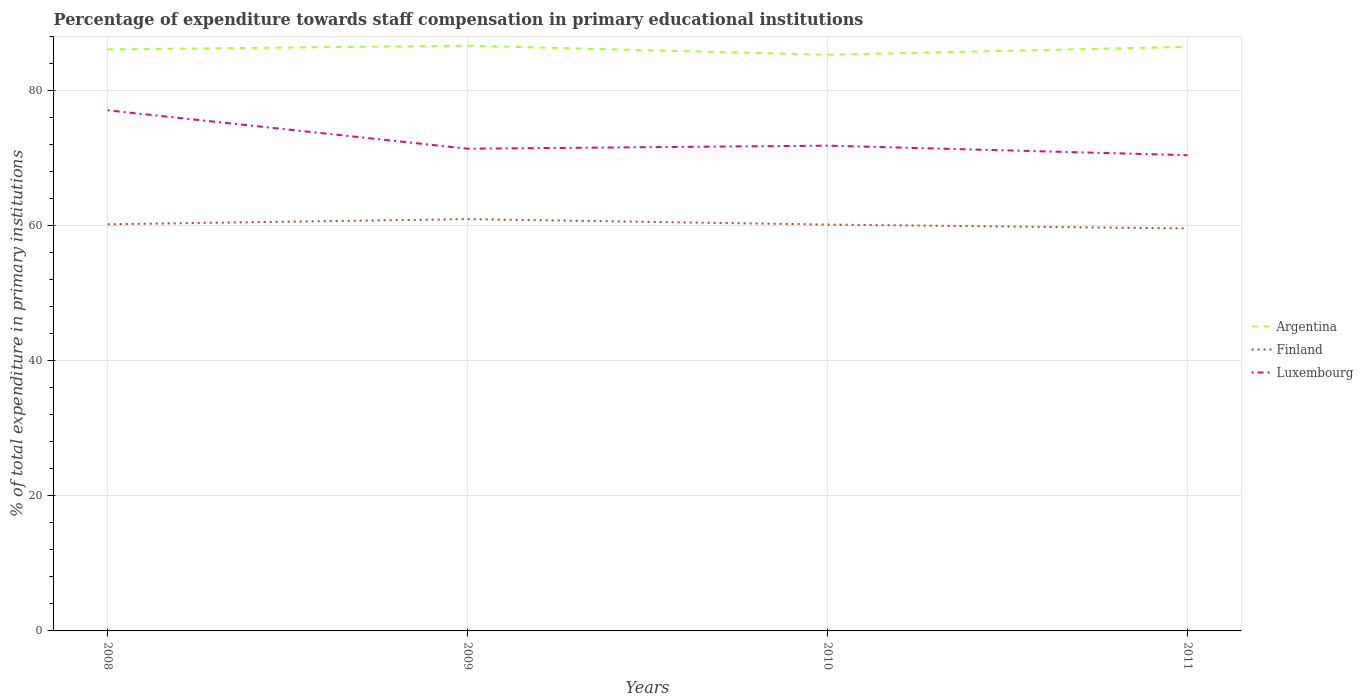Does the line corresponding to Luxembourg intersect with the line corresponding to Finland?
Make the answer very short. No. Across all years, what is the maximum percentage of expenditure towards staff compensation in Finland?
Keep it short and to the point. 59.62. In which year was the percentage of expenditure towards staff compensation in Luxembourg maximum?
Offer a very short reply. 2011. What is the total percentage of expenditure towards staff compensation in Finland in the graph?
Provide a short and direct response. 0.05. What is the difference between the highest and the second highest percentage of expenditure towards staff compensation in Luxembourg?
Your response must be concise. 6.65. What is the difference between the highest and the lowest percentage of expenditure towards staff compensation in Luxembourg?
Provide a short and direct response. 1. Is the percentage of expenditure towards staff compensation in Argentina strictly greater than the percentage of expenditure towards staff compensation in Luxembourg over the years?
Give a very brief answer. No. How many lines are there?
Ensure brevity in your answer.  3. How many years are there in the graph?
Offer a terse response. 4. What is the difference between two consecutive major ticks on the Y-axis?
Keep it short and to the point. 20. Are the values on the major ticks of Y-axis written in scientific E-notation?
Keep it short and to the point. No. Does the graph contain any zero values?
Offer a terse response. No. Does the graph contain grids?
Offer a very short reply. Yes. What is the title of the graph?
Ensure brevity in your answer.  Percentage of expenditure towards staff compensation in primary educational institutions. Does "Burkina Faso" appear as one of the legend labels in the graph?
Offer a terse response. No. What is the label or title of the X-axis?
Make the answer very short. Years. What is the label or title of the Y-axis?
Give a very brief answer. % of total expenditure in primary institutions. What is the % of total expenditure in primary institutions of Argentina in 2008?
Offer a terse response. 86.15. What is the % of total expenditure in primary institutions in Finland in 2008?
Provide a short and direct response. 60.24. What is the % of total expenditure in primary institutions in Luxembourg in 2008?
Your answer should be compact. 77.13. What is the % of total expenditure in primary institutions in Argentina in 2009?
Your answer should be very brief. 86.7. What is the % of total expenditure in primary institutions of Finland in 2009?
Keep it short and to the point. 61.01. What is the % of total expenditure in primary institutions of Luxembourg in 2009?
Your answer should be compact. 71.44. What is the % of total expenditure in primary institutions in Argentina in 2010?
Your answer should be very brief. 85.36. What is the % of total expenditure in primary institutions of Finland in 2010?
Keep it short and to the point. 60.2. What is the % of total expenditure in primary institutions in Luxembourg in 2010?
Your response must be concise. 71.89. What is the % of total expenditure in primary institutions of Argentina in 2011?
Offer a terse response. 86.53. What is the % of total expenditure in primary institutions in Finland in 2011?
Give a very brief answer. 59.62. What is the % of total expenditure in primary institutions in Luxembourg in 2011?
Provide a short and direct response. 70.48. Across all years, what is the maximum % of total expenditure in primary institutions of Argentina?
Your answer should be very brief. 86.7. Across all years, what is the maximum % of total expenditure in primary institutions of Finland?
Offer a terse response. 61.01. Across all years, what is the maximum % of total expenditure in primary institutions of Luxembourg?
Your answer should be very brief. 77.13. Across all years, what is the minimum % of total expenditure in primary institutions of Argentina?
Your response must be concise. 85.36. Across all years, what is the minimum % of total expenditure in primary institutions of Finland?
Your response must be concise. 59.62. Across all years, what is the minimum % of total expenditure in primary institutions of Luxembourg?
Make the answer very short. 70.48. What is the total % of total expenditure in primary institutions of Argentina in the graph?
Keep it short and to the point. 344.74. What is the total % of total expenditure in primary institutions of Finland in the graph?
Keep it short and to the point. 241.07. What is the total % of total expenditure in primary institutions of Luxembourg in the graph?
Your answer should be very brief. 290.94. What is the difference between the % of total expenditure in primary institutions of Argentina in 2008 and that in 2009?
Give a very brief answer. -0.55. What is the difference between the % of total expenditure in primary institutions in Finland in 2008 and that in 2009?
Ensure brevity in your answer.  -0.76. What is the difference between the % of total expenditure in primary institutions of Luxembourg in 2008 and that in 2009?
Offer a terse response. 5.69. What is the difference between the % of total expenditure in primary institutions in Argentina in 2008 and that in 2010?
Make the answer very short. 0.8. What is the difference between the % of total expenditure in primary institutions of Finland in 2008 and that in 2010?
Your answer should be compact. 0.05. What is the difference between the % of total expenditure in primary institutions in Luxembourg in 2008 and that in 2010?
Provide a short and direct response. 5.24. What is the difference between the % of total expenditure in primary institutions in Argentina in 2008 and that in 2011?
Ensure brevity in your answer.  -0.38. What is the difference between the % of total expenditure in primary institutions in Finland in 2008 and that in 2011?
Offer a terse response. 0.62. What is the difference between the % of total expenditure in primary institutions in Luxembourg in 2008 and that in 2011?
Give a very brief answer. 6.65. What is the difference between the % of total expenditure in primary institutions of Argentina in 2009 and that in 2010?
Keep it short and to the point. 1.34. What is the difference between the % of total expenditure in primary institutions in Finland in 2009 and that in 2010?
Your answer should be very brief. 0.81. What is the difference between the % of total expenditure in primary institutions of Luxembourg in 2009 and that in 2010?
Ensure brevity in your answer.  -0.45. What is the difference between the % of total expenditure in primary institutions in Argentina in 2009 and that in 2011?
Your answer should be compact. 0.17. What is the difference between the % of total expenditure in primary institutions of Finland in 2009 and that in 2011?
Offer a terse response. 1.38. What is the difference between the % of total expenditure in primary institutions in Luxembourg in 2009 and that in 2011?
Provide a succinct answer. 0.96. What is the difference between the % of total expenditure in primary institutions of Argentina in 2010 and that in 2011?
Your answer should be compact. -1.17. What is the difference between the % of total expenditure in primary institutions in Finland in 2010 and that in 2011?
Offer a terse response. 0.57. What is the difference between the % of total expenditure in primary institutions of Luxembourg in 2010 and that in 2011?
Your response must be concise. 1.41. What is the difference between the % of total expenditure in primary institutions in Argentina in 2008 and the % of total expenditure in primary institutions in Finland in 2009?
Your answer should be very brief. 25.14. What is the difference between the % of total expenditure in primary institutions of Argentina in 2008 and the % of total expenditure in primary institutions of Luxembourg in 2009?
Your response must be concise. 14.71. What is the difference between the % of total expenditure in primary institutions in Finland in 2008 and the % of total expenditure in primary institutions in Luxembourg in 2009?
Make the answer very short. -11.19. What is the difference between the % of total expenditure in primary institutions of Argentina in 2008 and the % of total expenditure in primary institutions of Finland in 2010?
Your answer should be compact. 25.95. What is the difference between the % of total expenditure in primary institutions in Argentina in 2008 and the % of total expenditure in primary institutions in Luxembourg in 2010?
Give a very brief answer. 14.26. What is the difference between the % of total expenditure in primary institutions of Finland in 2008 and the % of total expenditure in primary institutions of Luxembourg in 2010?
Offer a very short reply. -11.65. What is the difference between the % of total expenditure in primary institutions of Argentina in 2008 and the % of total expenditure in primary institutions of Finland in 2011?
Provide a short and direct response. 26.53. What is the difference between the % of total expenditure in primary institutions of Argentina in 2008 and the % of total expenditure in primary institutions of Luxembourg in 2011?
Ensure brevity in your answer.  15.67. What is the difference between the % of total expenditure in primary institutions of Finland in 2008 and the % of total expenditure in primary institutions of Luxembourg in 2011?
Offer a terse response. -10.24. What is the difference between the % of total expenditure in primary institutions in Argentina in 2009 and the % of total expenditure in primary institutions in Finland in 2010?
Provide a short and direct response. 26.5. What is the difference between the % of total expenditure in primary institutions of Argentina in 2009 and the % of total expenditure in primary institutions of Luxembourg in 2010?
Keep it short and to the point. 14.81. What is the difference between the % of total expenditure in primary institutions of Finland in 2009 and the % of total expenditure in primary institutions of Luxembourg in 2010?
Give a very brief answer. -10.89. What is the difference between the % of total expenditure in primary institutions in Argentina in 2009 and the % of total expenditure in primary institutions in Finland in 2011?
Give a very brief answer. 27.07. What is the difference between the % of total expenditure in primary institutions in Argentina in 2009 and the % of total expenditure in primary institutions in Luxembourg in 2011?
Make the answer very short. 16.22. What is the difference between the % of total expenditure in primary institutions of Finland in 2009 and the % of total expenditure in primary institutions of Luxembourg in 2011?
Provide a short and direct response. -9.47. What is the difference between the % of total expenditure in primary institutions of Argentina in 2010 and the % of total expenditure in primary institutions of Finland in 2011?
Offer a very short reply. 25.73. What is the difference between the % of total expenditure in primary institutions in Argentina in 2010 and the % of total expenditure in primary institutions in Luxembourg in 2011?
Provide a short and direct response. 14.88. What is the difference between the % of total expenditure in primary institutions in Finland in 2010 and the % of total expenditure in primary institutions in Luxembourg in 2011?
Provide a short and direct response. -10.28. What is the average % of total expenditure in primary institutions in Argentina per year?
Keep it short and to the point. 86.18. What is the average % of total expenditure in primary institutions in Finland per year?
Make the answer very short. 60.27. What is the average % of total expenditure in primary institutions in Luxembourg per year?
Keep it short and to the point. 72.73. In the year 2008, what is the difference between the % of total expenditure in primary institutions of Argentina and % of total expenditure in primary institutions of Finland?
Ensure brevity in your answer.  25.91. In the year 2008, what is the difference between the % of total expenditure in primary institutions of Argentina and % of total expenditure in primary institutions of Luxembourg?
Keep it short and to the point. 9.02. In the year 2008, what is the difference between the % of total expenditure in primary institutions in Finland and % of total expenditure in primary institutions in Luxembourg?
Offer a very short reply. -16.88. In the year 2009, what is the difference between the % of total expenditure in primary institutions of Argentina and % of total expenditure in primary institutions of Finland?
Your answer should be very brief. 25.69. In the year 2009, what is the difference between the % of total expenditure in primary institutions of Argentina and % of total expenditure in primary institutions of Luxembourg?
Make the answer very short. 15.26. In the year 2009, what is the difference between the % of total expenditure in primary institutions in Finland and % of total expenditure in primary institutions in Luxembourg?
Offer a very short reply. -10.43. In the year 2010, what is the difference between the % of total expenditure in primary institutions of Argentina and % of total expenditure in primary institutions of Finland?
Give a very brief answer. 25.16. In the year 2010, what is the difference between the % of total expenditure in primary institutions in Argentina and % of total expenditure in primary institutions in Luxembourg?
Provide a succinct answer. 13.46. In the year 2010, what is the difference between the % of total expenditure in primary institutions in Finland and % of total expenditure in primary institutions in Luxembourg?
Your answer should be very brief. -11.69. In the year 2011, what is the difference between the % of total expenditure in primary institutions of Argentina and % of total expenditure in primary institutions of Finland?
Your response must be concise. 26.91. In the year 2011, what is the difference between the % of total expenditure in primary institutions in Argentina and % of total expenditure in primary institutions in Luxembourg?
Your answer should be very brief. 16.05. In the year 2011, what is the difference between the % of total expenditure in primary institutions in Finland and % of total expenditure in primary institutions in Luxembourg?
Keep it short and to the point. -10.86. What is the ratio of the % of total expenditure in primary institutions of Argentina in 2008 to that in 2009?
Your answer should be very brief. 0.99. What is the ratio of the % of total expenditure in primary institutions of Finland in 2008 to that in 2009?
Provide a short and direct response. 0.99. What is the ratio of the % of total expenditure in primary institutions of Luxembourg in 2008 to that in 2009?
Give a very brief answer. 1.08. What is the ratio of the % of total expenditure in primary institutions of Argentina in 2008 to that in 2010?
Make the answer very short. 1.01. What is the ratio of the % of total expenditure in primary institutions in Luxembourg in 2008 to that in 2010?
Provide a succinct answer. 1.07. What is the ratio of the % of total expenditure in primary institutions in Finland in 2008 to that in 2011?
Provide a short and direct response. 1.01. What is the ratio of the % of total expenditure in primary institutions in Luxembourg in 2008 to that in 2011?
Provide a short and direct response. 1.09. What is the ratio of the % of total expenditure in primary institutions of Argentina in 2009 to that in 2010?
Make the answer very short. 1.02. What is the ratio of the % of total expenditure in primary institutions in Finland in 2009 to that in 2010?
Provide a succinct answer. 1.01. What is the ratio of the % of total expenditure in primary institutions in Luxembourg in 2009 to that in 2010?
Provide a succinct answer. 0.99. What is the ratio of the % of total expenditure in primary institutions in Finland in 2009 to that in 2011?
Provide a short and direct response. 1.02. What is the ratio of the % of total expenditure in primary institutions in Luxembourg in 2009 to that in 2011?
Offer a very short reply. 1.01. What is the ratio of the % of total expenditure in primary institutions of Argentina in 2010 to that in 2011?
Provide a short and direct response. 0.99. What is the ratio of the % of total expenditure in primary institutions in Finland in 2010 to that in 2011?
Your response must be concise. 1.01. What is the difference between the highest and the second highest % of total expenditure in primary institutions of Argentina?
Keep it short and to the point. 0.17. What is the difference between the highest and the second highest % of total expenditure in primary institutions of Finland?
Give a very brief answer. 0.76. What is the difference between the highest and the second highest % of total expenditure in primary institutions in Luxembourg?
Provide a short and direct response. 5.24. What is the difference between the highest and the lowest % of total expenditure in primary institutions of Argentina?
Offer a very short reply. 1.34. What is the difference between the highest and the lowest % of total expenditure in primary institutions of Finland?
Offer a very short reply. 1.38. What is the difference between the highest and the lowest % of total expenditure in primary institutions in Luxembourg?
Make the answer very short. 6.65. 